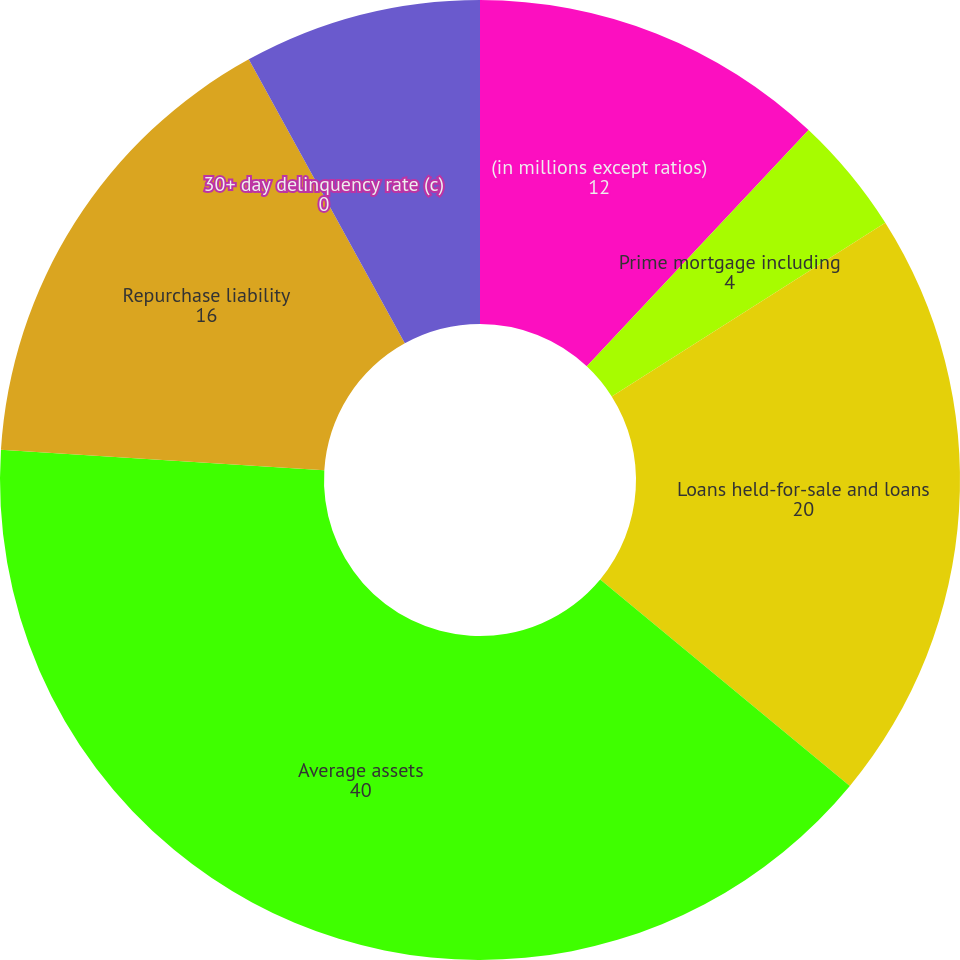Convert chart. <chart><loc_0><loc_0><loc_500><loc_500><pie_chart><fcel>(in millions except ratios)<fcel>Prime mortgage including<fcel>Loans held-for-sale and loans<fcel>Average assets<fcel>Repurchase liability<fcel>30+ day delinquency rate (c)<fcel>Nonperforming assets (d)<nl><fcel>12.0%<fcel>4.0%<fcel>20.0%<fcel>40.0%<fcel>16.0%<fcel>0.0%<fcel>8.0%<nl></chart> 